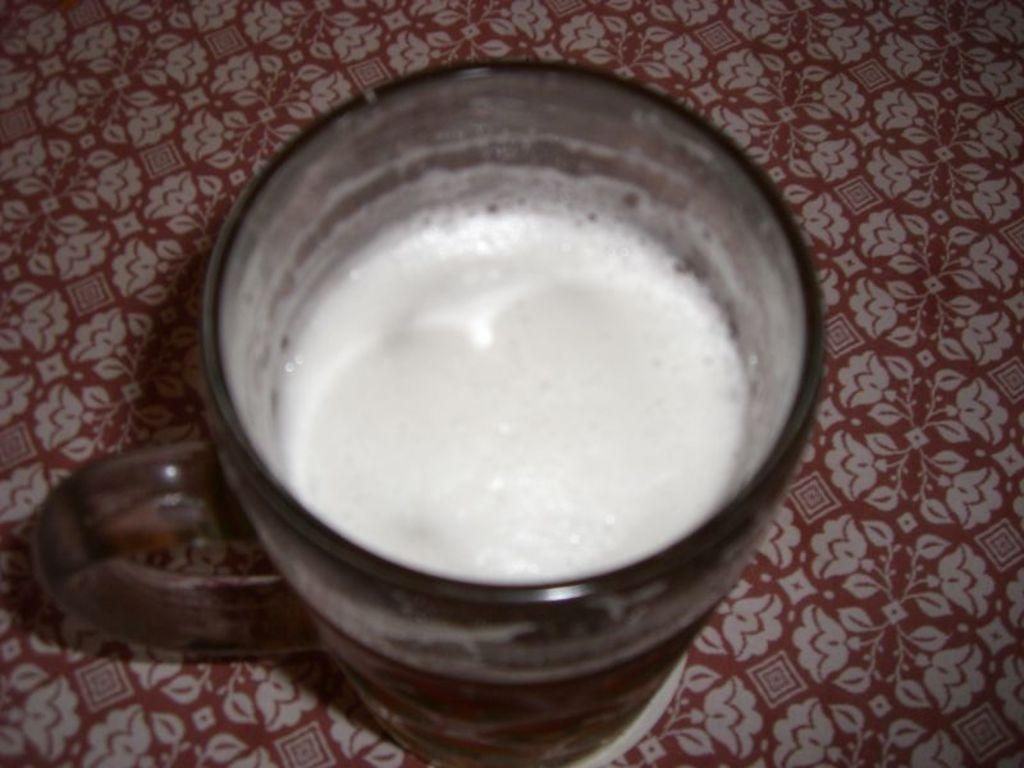What is in the cup that is visible in the image? There is a cup with liquid in the image. Where is the cup located in the image? The cup is placed on a surface. What can be seen on the surface where the cup is placed? There is a flowers print on the surface. Can you tell me how the river flows in the image? There is no river present in the image; it features a cup with liquid on a surface with a flowers print. 